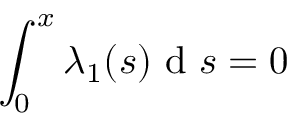Convert formula to latex. <formula><loc_0><loc_0><loc_500><loc_500>\int _ { 0 } ^ { x } \lambda _ { 1 } ( s ) d s = 0</formula> 